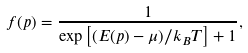<formula> <loc_0><loc_0><loc_500><loc_500>f ( p ) = \frac { 1 } { \exp \left [ ( E ( p ) - \mu ) / k _ { B } T \right ] + 1 } ,</formula> 